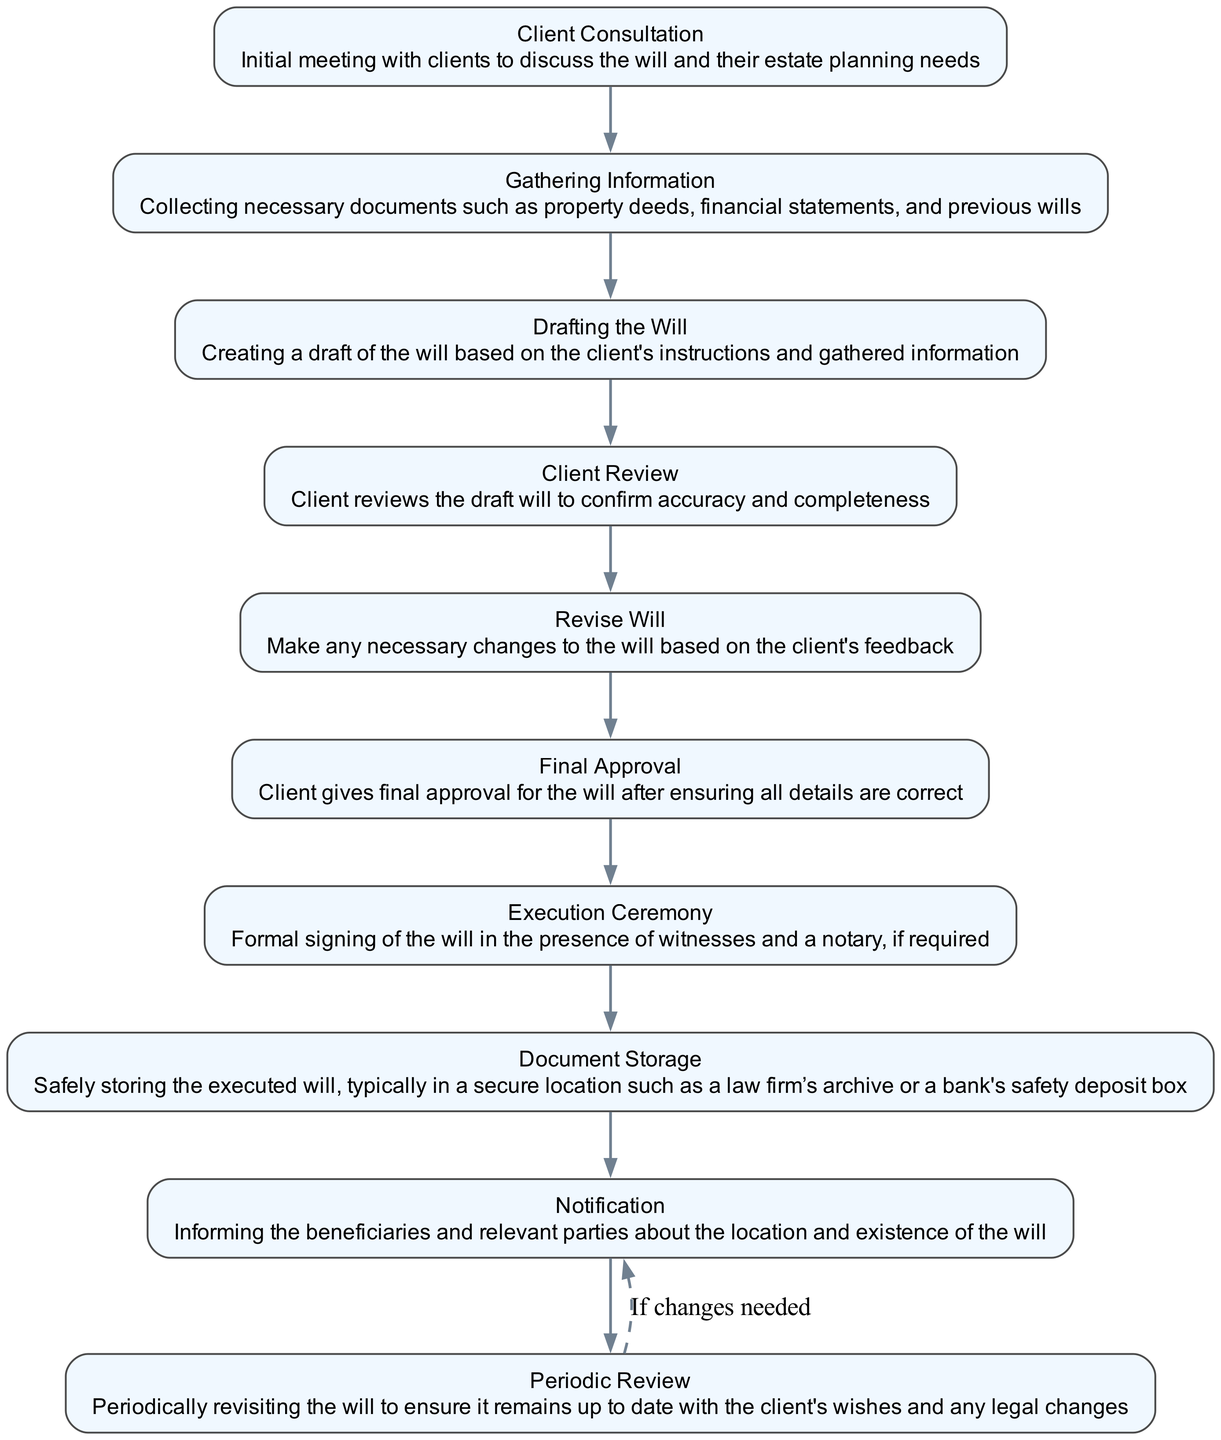What is the first step in the will execution process? The first step in the process is "Client Consultation" where initial meetings with clients are held to discuss will and estate planning needs.
Answer: Client Consultation How many total steps are outlined in the will execution process? The diagram presents ten distinct steps in the will execution process from the initial consultation to periodic review.
Answer: Ten What follows the "Drafting the Will"? After "Drafting the Will," the next step is "Client Review," where the client checks the draft for accuracy and completeness.
Answer: Client Review What is the final step in the execution process? The last step highlighted in the diagram is "Periodic Review," ensuring the will remains up-to-date with client wishes and legal changes.
Answer: Periodic Review What happens if changes are needed after the "Final Approval"? If changes are needed, the flow indicates a loop back to "Revise Will," allowing for modifications based on client feedback.
Answer: Revise Will Which step involves informing beneficiaries? The step designated for notifying beneficiaries about the will's location is "Notification."
Answer: Notification How is "Document Storage" described in the process? "Document Storage" involves safely storing the executed will in a secure location such as a law firm’s archive or safety deposit box.
Answer: Safely storing the executed will What is required during the "Execution Ceremony"? The "Execution Ceremony" requires the formal signing of the will in the presence of witnesses and, if necessary, a notary.
Answer: Formal signing in presence of witnesses Which two steps are directly linked before "Execution Ceremony"? The directly linked steps before "Execution Ceremony" are "Final Approval" and "Revise Will," indicating the need for client confirmation before execution.
Answer: Final Approval and Revise Will Where does the process loop back to if the client has feedback? The process loops back to "Revise Will" if the client has feedback that requires changes to the draft will.
Answer: Revise Will 